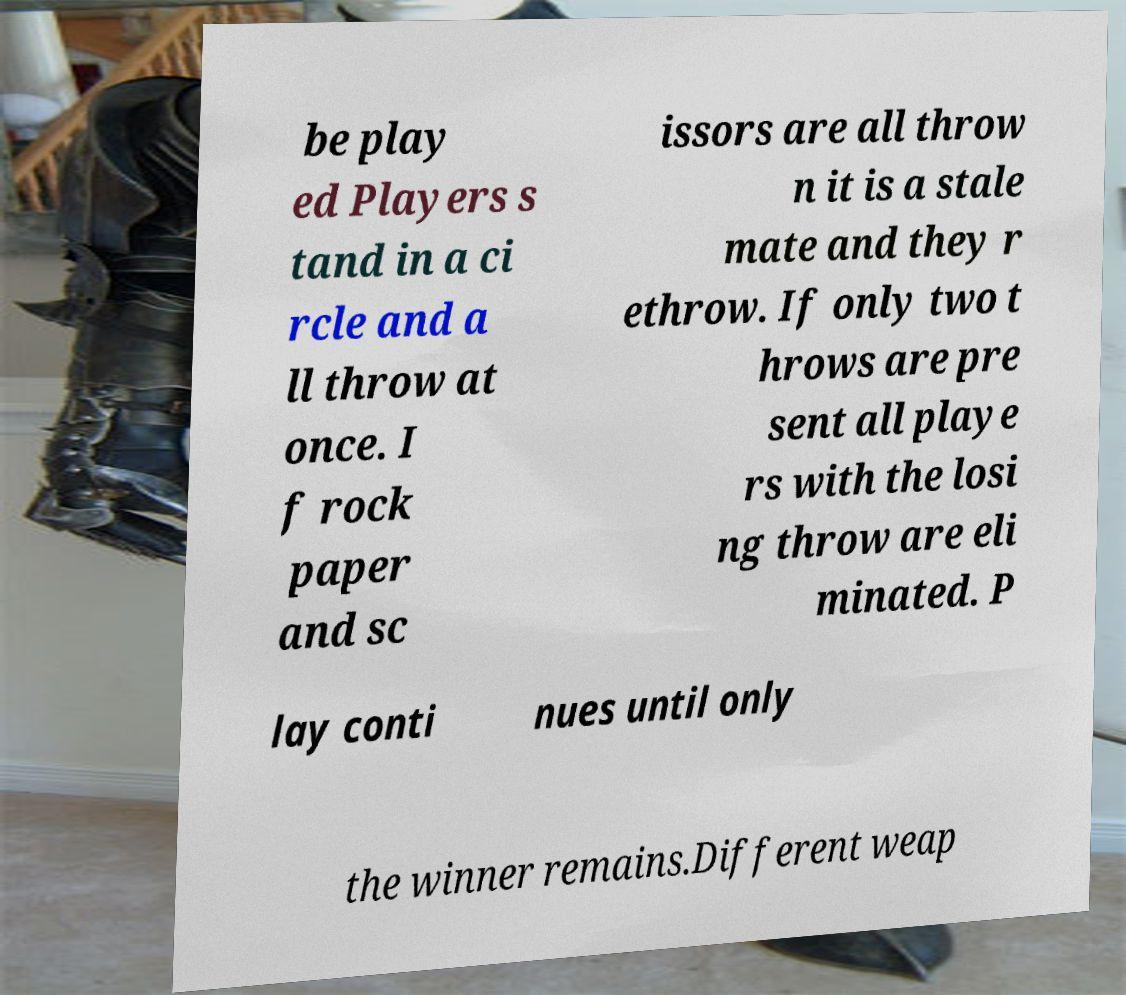What messages or text are displayed in this image? I need them in a readable, typed format. be play ed Players s tand in a ci rcle and a ll throw at once. I f rock paper and sc issors are all throw n it is a stale mate and they r ethrow. If only two t hrows are pre sent all playe rs with the losi ng throw are eli minated. P lay conti nues until only the winner remains.Different weap 